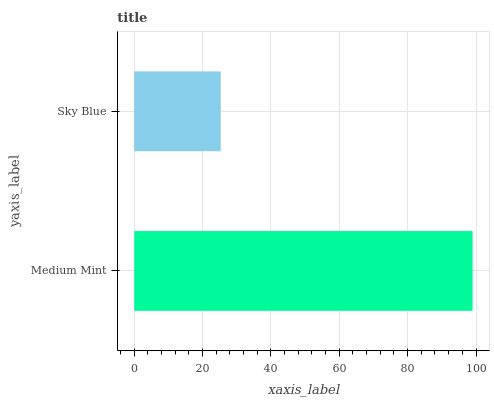Is Sky Blue the minimum?
Answer yes or no. Yes. Is Medium Mint the maximum?
Answer yes or no. Yes. Is Sky Blue the maximum?
Answer yes or no. No. Is Medium Mint greater than Sky Blue?
Answer yes or no. Yes. Is Sky Blue less than Medium Mint?
Answer yes or no. Yes. Is Sky Blue greater than Medium Mint?
Answer yes or no. No. Is Medium Mint less than Sky Blue?
Answer yes or no. No. Is Medium Mint the high median?
Answer yes or no. Yes. Is Sky Blue the low median?
Answer yes or no. Yes. Is Sky Blue the high median?
Answer yes or no. No. Is Medium Mint the low median?
Answer yes or no. No. 